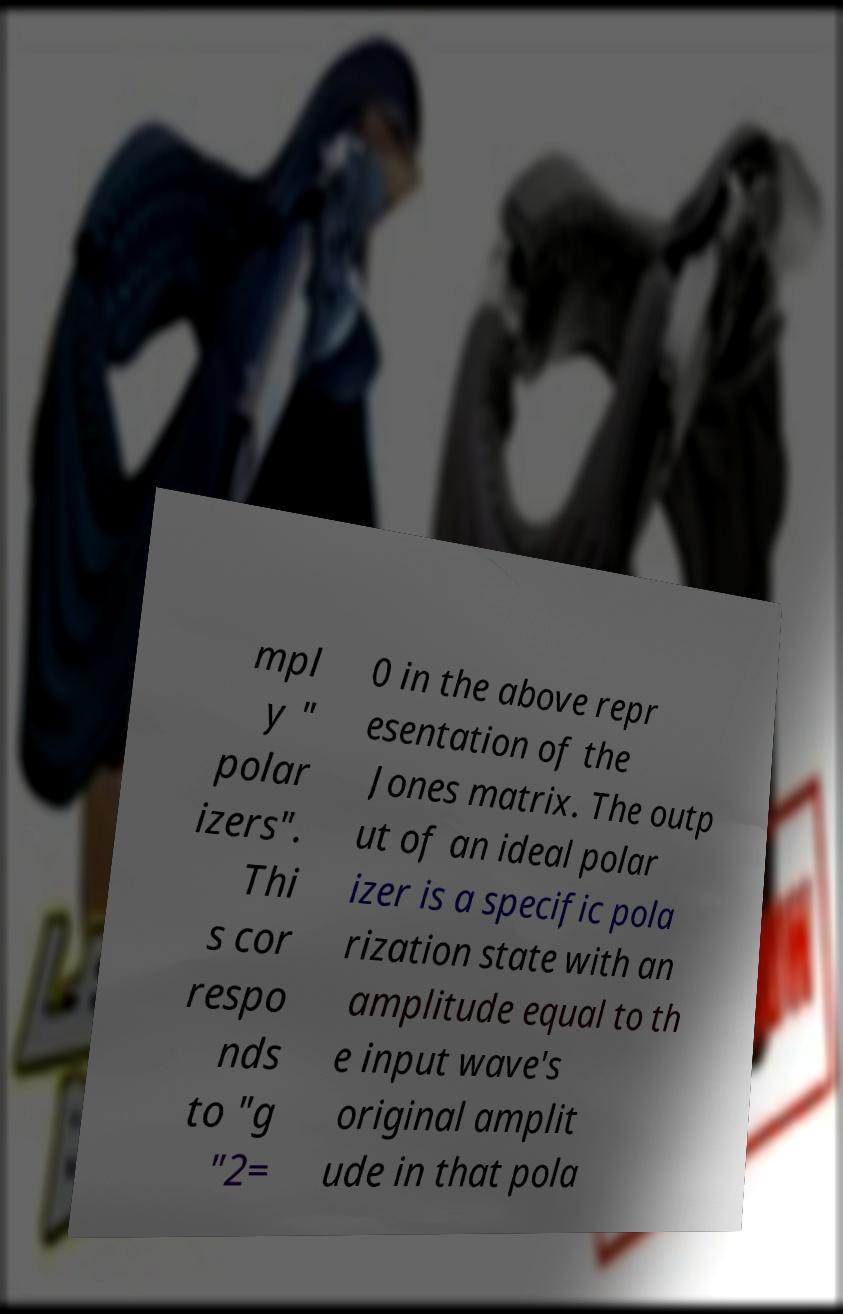Could you assist in decoding the text presented in this image and type it out clearly? mpl y " polar izers". Thi s cor respo nds to "g "2= 0 in the above repr esentation of the Jones matrix. The outp ut of an ideal polar izer is a specific pola rization state with an amplitude equal to th e input wave's original amplit ude in that pola 